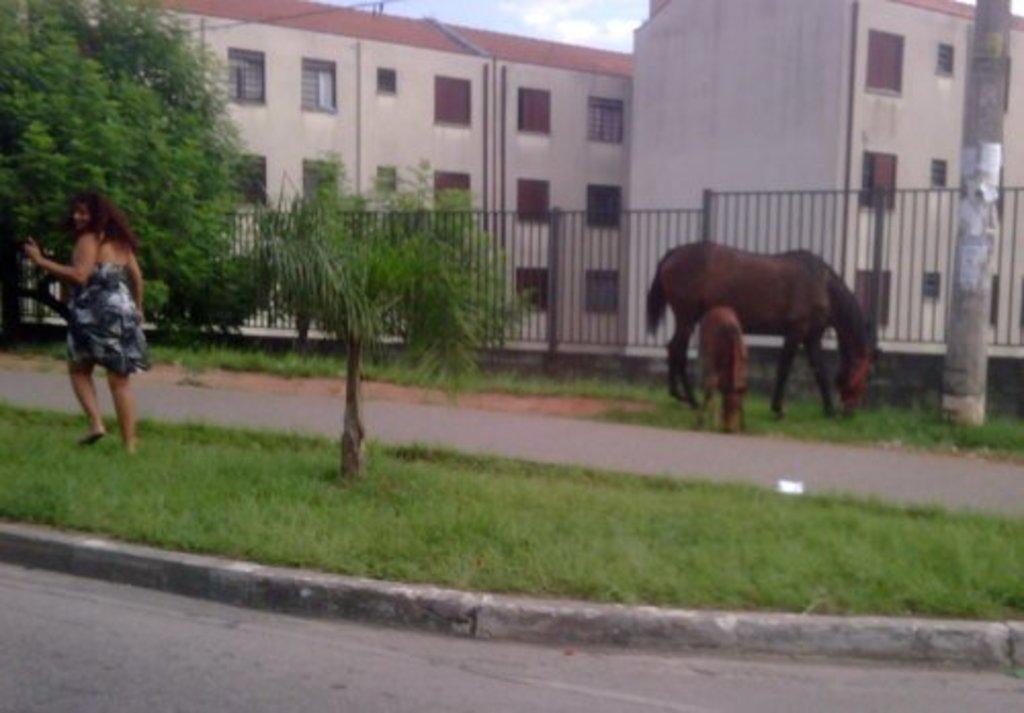What types of living organisms can be seen in the image? There are animals in the image. Can you describe the human presence in the image? There is a lady in the image. What type of pathway is visible in the image? There is a road in the image. What is the natural environment like in the image? The ground with grass is visible in the image, along with trees. What type of barrier is present in the image? There is fencing in the image. What type of vertical structures are present in the image? There are poles in the image. What type of structure with openings is visible in the image? There is a building with windows in the image. What part of the natural environment is visible in the image? The sky is visible in the image. Where is the lunchroom located in the image? There is no mention of a lunchroom in the image. How many horses are visible in the image? There are no horses present in the image. 